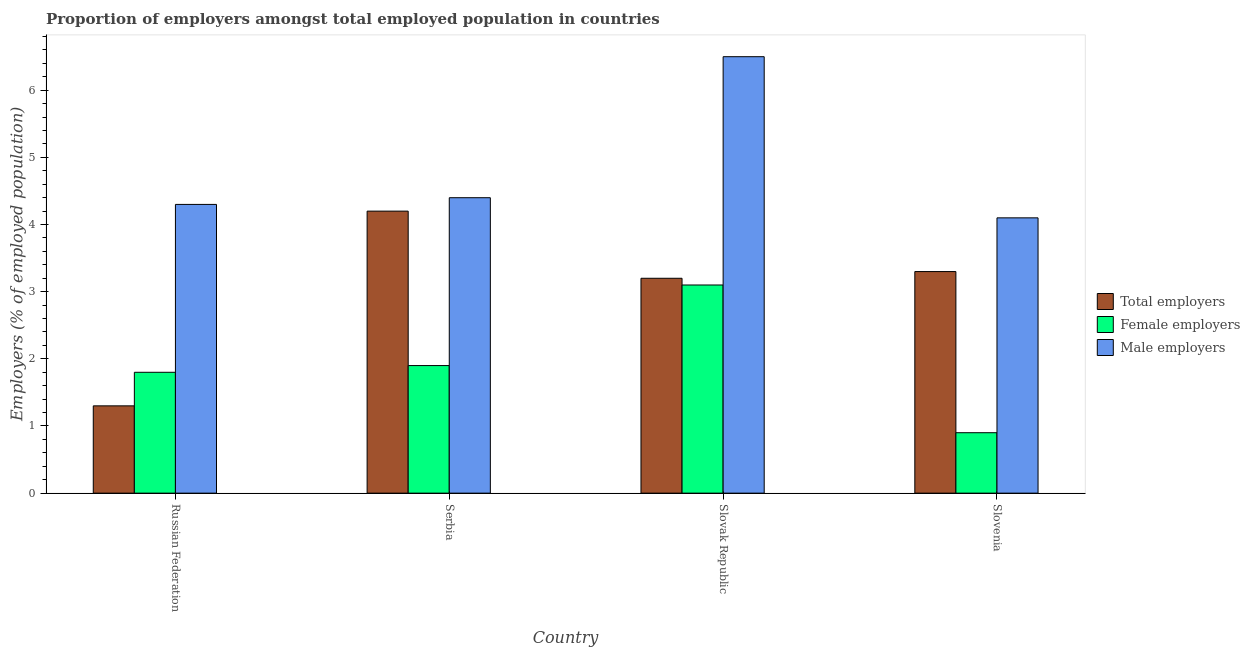How many groups of bars are there?
Ensure brevity in your answer.  4. Are the number of bars on each tick of the X-axis equal?
Your answer should be compact. Yes. What is the label of the 1st group of bars from the left?
Make the answer very short. Russian Federation. What is the percentage of total employers in Serbia?
Make the answer very short. 4.2. Across all countries, what is the maximum percentage of female employers?
Your answer should be compact. 3.1. Across all countries, what is the minimum percentage of total employers?
Ensure brevity in your answer.  1.3. In which country was the percentage of male employers maximum?
Ensure brevity in your answer.  Slovak Republic. In which country was the percentage of female employers minimum?
Offer a terse response. Slovenia. What is the total percentage of male employers in the graph?
Ensure brevity in your answer.  19.3. What is the difference between the percentage of female employers in Serbia and that in Slovak Republic?
Your response must be concise. -1.2. What is the difference between the percentage of male employers in Slovak Republic and the percentage of total employers in Serbia?
Keep it short and to the point. 2.3. What is the average percentage of female employers per country?
Your answer should be very brief. 1.92. What is the difference between the percentage of male employers and percentage of total employers in Slovak Republic?
Your response must be concise. 3.3. In how many countries, is the percentage of female employers greater than 1.6 %?
Offer a very short reply. 3. What is the ratio of the percentage of total employers in Russian Federation to that in Slovenia?
Make the answer very short. 0.39. What is the difference between the highest and the second highest percentage of total employers?
Make the answer very short. 0.9. What is the difference between the highest and the lowest percentage of male employers?
Make the answer very short. 2.4. What does the 1st bar from the left in Slovenia represents?
Make the answer very short. Total employers. What does the 1st bar from the right in Slovenia represents?
Your answer should be compact. Male employers. Is it the case that in every country, the sum of the percentage of total employers and percentage of female employers is greater than the percentage of male employers?
Provide a succinct answer. No. What is the difference between two consecutive major ticks on the Y-axis?
Your response must be concise. 1. Does the graph contain any zero values?
Keep it short and to the point. No. How many legend labels are there?
Your answer should be very brief. 3. What is the title of the graph?
Keep it short and to the point. Proportion of employers amongst total employed population in countries. Does "Grants" appear as one of the legend labels in the graph?
Offer a terse response. No. What is the label or title of the X-axis?
Ensure brevity in your answer.  Country. What is the label or title of the Y-axis?
Provide a short and direct response. Employers (% of employed population). What is the Employers (% of employed population) in Total employers in Russian Federation?
Provide a short and direct response. 1.3. What is the Employers (% of employed population) in Female employers in Russian Federation?
Your answer should be very brief. 1.8. What is the Employers (% of employed population) of Male employers in Russian Federation?
Ensure brevity in your answer.  4.3. What is the Employers (% of employed population) in Total employers in Serbia?
Provide a succinct answer. 4.2. What is the Employers (% of employed population) in Female employers in Serbia?
Provide a short and direct response. 1.9. What is the Employers (% of employed population) in Male employers in Serbia?
Your answer should be compact. 4.4. What is the Employers (% of employed population) in Total employers in Slovak Republic?
Offer a very short reply. 3.2. What is the Employers (% of employed population) of Female employers in Slovak Republic?
Provide a succinct answer. 3.1. What is the Employers (% of employed population) in Total employers in Slovenia?
Give a very brief answer. 3.3. What is the Employers (% of employed population) of Female employers in Slovenia?
Your answer should be very brief. 0.9. What is the Employers (% of employed population) of Male employers in Slovenia?
Keep it short and to the point. 4.1. Across all countries, what is the maximum Employers (% of employed population) in Total employers?
Offer a terse response. 4.2. Across all countries, what is the maximum Employers (% of employed population) of Female employers?
Ensure brevity in your answer.  3.1. Across all countries, what is the maximum Employers (% of employed population) of Male employers?
Your response must be concise. 6.5. Across all countries, what is the minimum Employers (% of employed population) of Total employers?
Your answer should be very brief. 1.3. Across all countries, what is the minimum Employers (% of employed population) in Female employers?
Ensure brevity in your answer.  0.9. Across all countries, what is the minimum Employers (% of employed population) of Male employers?
Keep it short and to the point. 4.1. What is the total Employers (% of employed population) of Male employers in the graph?
Your response must be concise. 19.3. What is the difference between the Employers (% of employed population) of Total employers in Russian Federation and that in Serbia?
Offer a very short reply. -2.9. What is the difference between the Employers (% of employed population) in Male employers in Russian Federation and that in Serbia?
Provide a succinct answer. -0.1. What is the difference between the Employers (% of employed population) in Male employers in Russian Federation and that in Slovak Republic?
Offer a terse response. -2.2. What is the difference between the Employers (% of employed population) in Total employers in Russian Federation and that in Slovenia?
Your answer should be compact. -2. What is the difference between the Employers (% of employed population) of Female employers in Russian Federation and that in Slovenia?
Ensure brevity in your answer.  0.9. What is the difference between the Employers (% of employed population) in Total employers in Serbia and that in Slovak Republic?
Ensure brevity in your answer.  1. What is the difference between the Employers (% of employed population) in Male employers in Serbia and that in Slovak Republic?
Your answer should be very brief. -2.1. What is the difference between the Employers (% of employed population) of Female employers in Serbia and that in Slovenia?
Your response must be concise. 1. What is the difference between the Employers (% of employed population) of Male employers in Serbia and that in Slovenia?
Offer a very short reply. 0.3. What is the difference between the Employers (% of employed population) of Total employers in Slovak Republic and that in Slovenia?
Your answer should be very brief. -0.1. What is the difference between the Employers (% of employed population) of Female employers in Slovak Republic and that in Slovenia?
Give a very brief answer. 2.2. What is the difference between the Employers (% of employed population) in Male employers in Slovak Republic and that in Slovenia?
Your answer should be compact. 2.4. What is the difference between the Employers (% of employed population) in Total employers in Russian Federation and the Employers (% of employed population) in Male employers in Slovak Republic?
Your response must be concise. -5.2. What is the difference between the Employers (% of employed population) of Female employers in Russian Federation and the Employers (% of employed population) of Male employers in Slovak Republic?
Your answer should be compact. -4.7. What is the difference between the Employers (% of employed population) of Female employers in Serbia and the Employers (% of employed population) of Male employers in Slovak Republic?
Your answer should be compact. -4.6. What is the difference between the Employers (% of employed population) in Total employers in Slovak Republic and the Employers (% of employed population) in Male employers in Slovenia?
Give a very brief answer. -0.9. What is the difference between the Employers (% of employed population) of Female employers in Slovak Republic and the Employers (% of employed population) of Male employers in Slovenia?
Make the answer very short. -1. What is the average Employers (% of employed population) in Female employers per country?
Make the answer very short. 1.93. What is the average Employers (% of employed population) in Male employers per country?
Provide a succinct answer. 4.83. What is the difference between the Employers (% of employed population) in Total employers and Employers (% of employed population) in Female employers in Russian Federation?
Your answer should be compact. -0.5. What is the difference between the Employers (% of employed population) of Total employers and Employers (% of employed population) of Male employers in Russian Federation?
Your response must be concise. -3. What is the difference between the Employers (% of employed population) of Female employers and Employers (% of employed population) of Male employers in Russian Federation?
Your answer should be compact. -2.5. What is the difference between the Employers (% of employed population) in Total employers and Employers (% of employed population) in Male employers in Serbia?
Keep it short and to the point. -0.2. What is the difference between the Employers (% of employed population) in Female employers and Employers (% of employed population) in Male employers in Serbia?
Keep it short and to the point. -2.5. What is the difference between the Employers (% of employed population) in Total employers and Employers (% of employed population) in Male employers in Slovak Republic?
Keep it short and to the point. -3.3. What is the difference between the Employers (% of employed population) in Female employers and Employers (% of employed population) in Male employers in Slovenia?
Your answer should be compact. -3.2. What is the ratio of the Employers (% of employed population) in Total employers in Russian Federation to that in Serbia?
Keep it short and to the point. 0.31. What is the ratio of the Employers (% of employed population) of Female employers in Russian Federation to that in Serbia?
Your answer should be very brief. 0.95. What is the ratio of the Employers (% of employed population) of Male employers in Russian Federation to that in Serbia?
Offer a very short reply. 0.98. What is the ratio of the Employers (% of employed population) in Total employers in Russian Federation to that in Slovak Republic?
Keep it short and to the point. 0.41. What is the ratio of the Employers (% of employed population) of Female employers in Russian Federation to that in Slovak Republic?
Give a very brief answer. 0.58. What is the ratio of the Employers (% of employed population) in Male employers in Russian Federation to that in Slovak Republic?
Keep it short and to the point. 0.66. What is the ratio of the Employers (% of employed population) of Total employers in Russian Federation to that in Slovenia?
Offer a terse response. 0.39. What is the ratio of the Employers (% of employed population) in Male employers in Russian Federation to that in Slovenia?
Keep it short and to the point. 1.05. What is the ratio of the Employers (% of employed population) of Total employers in Serbia to that in Slovak Republic?
Make the answer very short. 1.31. What is the ratio of the Employers (% of employed population) of Female employers in Serbia to that in Slovak Republic?
Your answer should be very brief. 0.61. What is the ratio of the Employers (% of employed population) in Male employers in Serbia to that in Slovak Republic?
Your answer should be compact. 0.68. What is the ratio of the Employers (% of employed population) of Total employers in Serbia to that in Slovenia?
Give a very brief answer. 1.27. What is the ratio of the Employers (% of employed population) of Female employers in Serbia to that in Slovenia?
Offer a very short reply. 2.11. What is the ratio of the Employers (% of employed population) in Male employers in Serbia to that in Slovenia?
Ensure brevity in your answer.  1.07. What is the ratio of the Employers (% of employed population) of Total employers in Slovak Republic to that in Slovenia?
Your answer should be compact. 0.97. What is the ratio of the Employers (% of employed population) in Female employers in Slovak Republic to that in Slovenia?
Make the answer very short. 3.44. What is the ratio of the Employers (% of employed population) in Male employers in Slovak Republic to that in Slovenia?
Give a very brief answer. 1.59. What is the difference between the highest and the second highest Employers (% of employed population) in Total employers?
Your response must be concise. 0.9. What is the difference between the highest and the second highest Employers (% of employed population) of Male employers?
Give a very brief answer. 2.1. What is the difference between the highest and the lowest Employers (% of employed population) of Male employers?
Provide a succinct answer. 2.4. 